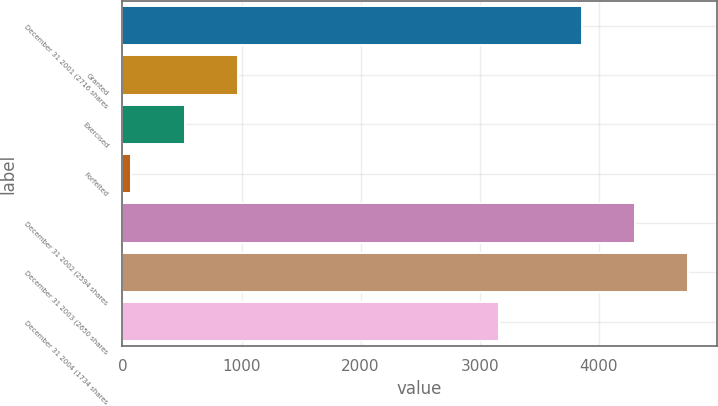Convert chart to OTSL. <chart><loc_0><loc_0><loc_500><loc_500><bar_chart><fcel>December 31 2001 (2716 shares<fcel>Granted<fcel>Exercised<fcel>Forfeited<fcel>December 31 2002 (2594 shares<fcel>December 31 2003 (2650 shares<fcel>December 31 2004 (1734 shares<nl><fcel>3855<fcel>971.2<fcel>523.1<fcel>75<fcel>4303.1<fcel>4751.2<fcel>3162<nl></chart> 